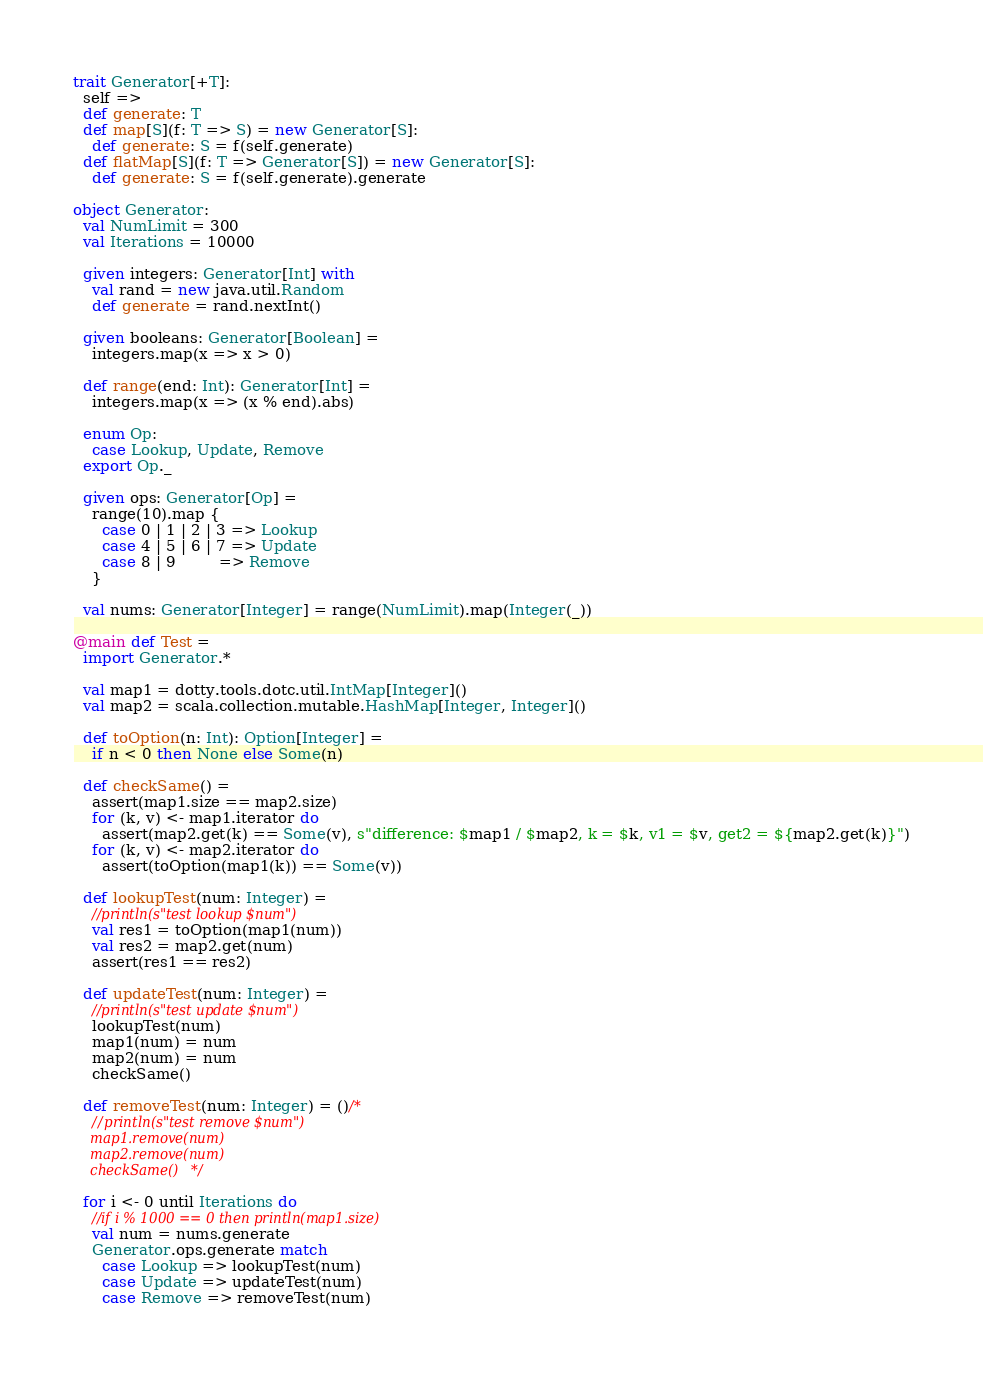Convert code to text. <code><loc_0><loc_0><loc_500><loc_500><_Scala_>trait Generator[+T]:
  self =>
  def generate: T
  def map[S](f: T => S) = new Generator[S]:
    def generate: S = f(self.generate)
  def flatMap[S](f: T => Generator[S]) = new Generator[S]:
    def generate: S = f(self.generate).generate

object Generator:
  val NumLimit = 300
  val Iterations = 10000

  given integers: Generator[Int] with
    val rand = new java.util.Random
    def generate = rand.nextInt()

  given booleans: Generator[Boolean] =
    integers.map(x => x > 0)

  def range(end: Int): Generator[Int] =
    integers.map(x => (x % end).abs)

  enum Op:
    case Lookup, Update, Remove
  export Op._

  given ops: Generator[Op] =
    range(10).map {
      case 0 | 1 | 2 | 3 => Lookup
      case 4 | 5 | 6 | 7 => Update
      case 8 | 9         => Remove
    }

  val nums: Generator[Integer] = range(NumLimit).map(Integer(_))

@main def Test =
  import Generator.*

  val map1 = dotty.tools.dotc.util.IntMap[Integer]()
  val map2 = scala.collection.mutable.HashMap[Integer, Integer]()

  def toOption(n: Int): Option[Integer] =
    if n < 0 then None else Some(n)

  def checkSame() =
    assert(map1.size == map2.size)
    for (k, v) <- map1.iterator do
      assert(map2.get(k) == Some(v), s"difference: $map1 / $map2, k = $k, v1 = $v, get2 = ${map2.get(k)}")
    for (k, v) <- map2.iterator do
      assert(toOption(map1(k)) == Some(v))

  def lookupTest(num: Integer) =
    //println(s"test lookup $num")
    val res1 = toOption(map1(num))
    val res2 = map2.get(num)
    assert(res1 == res2)

  def updateTest(num: Integer) =
    //println(s"test update $num")
    lookupTest(num)
    map1(num) = num
    map2(num) = num
    checkSame()

  def removeTest(num: Integer) = ()/*
    //println(s"test remove $num")
    map1.remove(num)
    map2.remove(num)
    checkSame()*/

  for i <- 0 until Iterations do
    //if i % 1000 == 0 then println(map1.size)
    val num = nums.generate
    Generator.ops.generate match
      case Lookup => lookupTest(num)
      case Update => updateTest(num)
      case Remove => removeTest(num)
</code> 